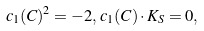Convert formula to latex. <formula><loc_0><loc_0><loc_500><loc_500>c _ { 1 } ( C ) ^ { 2 } = - 2 , \, c _ { 1 } ( C ) \cdot K _ { S } = 0 ,</formula> 